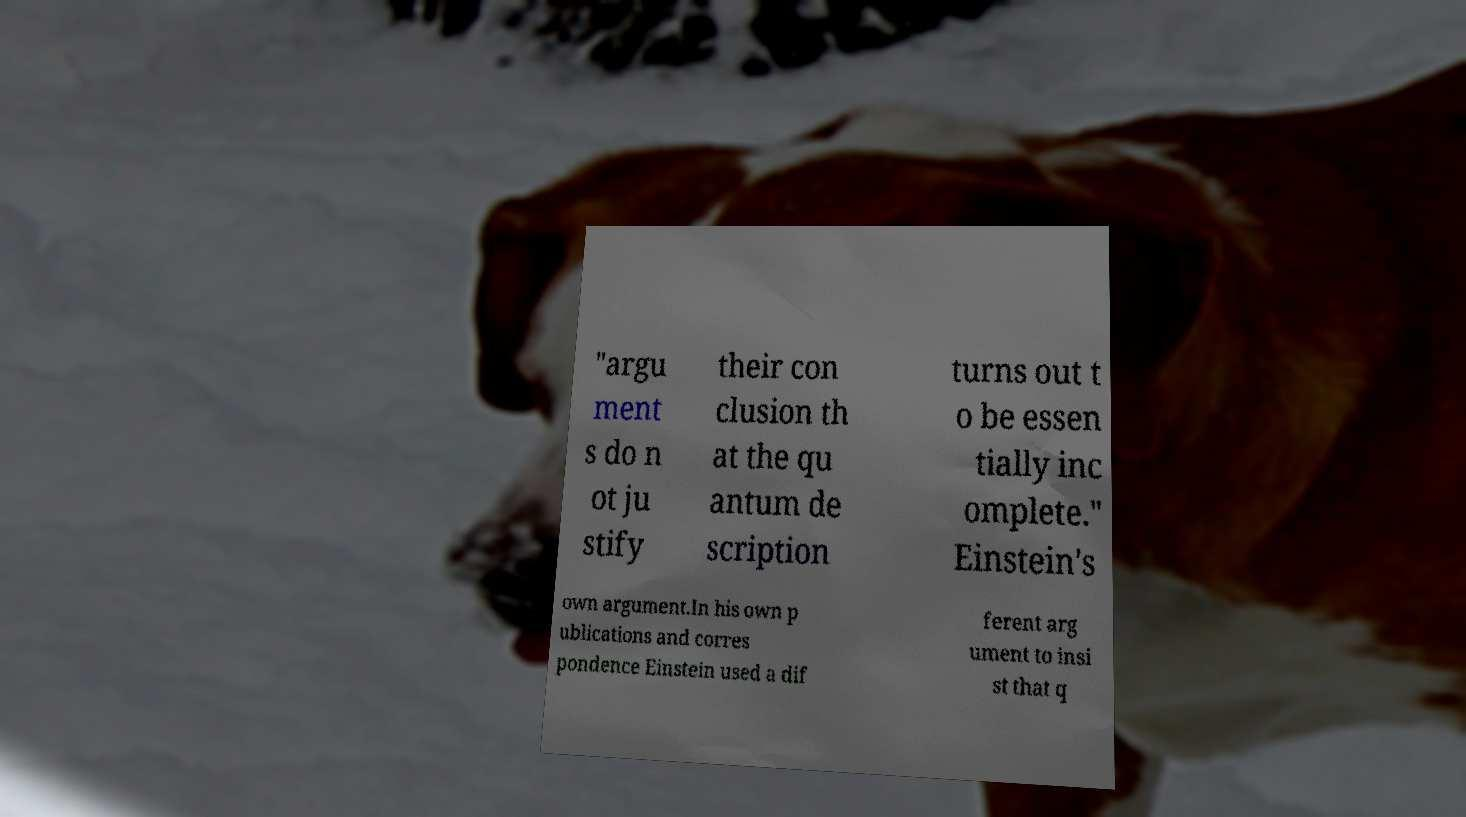There's text embedded in this image that I need extracted. Can you transcribe it verbatim? "argu ment s do n ot ju stify their con clusion th at the qu antum de scription turns out t o be essen tially inc omplete." Einstein's own argument.In his own p ublications and corres pondence Einstein used a dif ferent arg ument to insi st that q 